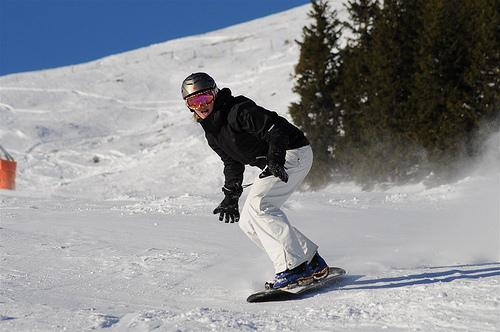Question: what sport is on display?
Choices:
A. Snowboarding.
B. Soccer.
C. Baseball.
D. Football.
Answer with the letter. Answer: A Question: where was the photo taken?
Choices:
A. Ski lodge.
B. Beach.
C. Mountains.
D. New York.
Answer with the letter. Answer: C Question: who is shown?
Choices:
A. Young man.
B. Young woman.
C. Snowboarder.
D. Married couple.
Answer with the letter. Answer: C Question: when was the photo taken?
Choices:
A. 1960s.
B. Christmas.
C. Spring break.
D. Winter.
Answer with the letter. Answer: D Question: what color is the ground?
Choices:
A. White.
B. Brown.
C. Tan.
D. Yellow.
Answer with the letter. Answer: A Question: how many people are shown?
Choices:
A. Two.
B. Three.
C. Four.
D. One.
Answer with the letter. Answer: D Question: why is the ground white?
Choices:
A. Concrete.
B. It's been painted.
C. Snow.
D. Ice.
Answer with the letter. Answer: C 